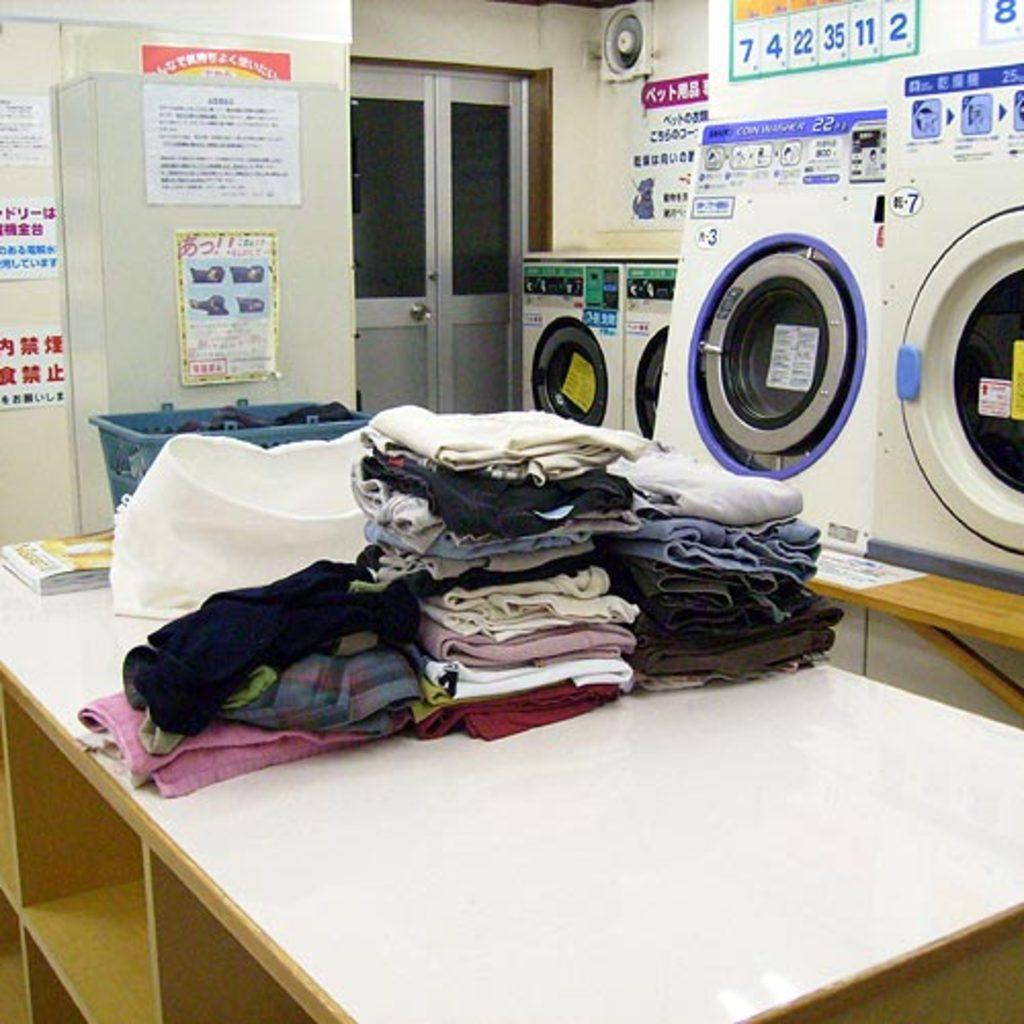What is the main piece of furniture in the image? The image contains a table. What items can be seen on the table? There are clothes, a basket, and a book on the table. What can be seen in the background of the image? There are washing machines, posters, and a cupboard in the background. What is the structure of the room visible in the image? The image contains a wall with a door in it. What type of crib is visible in the image? There is no crib present in the image. What kind of tools might a carpenter use in the image? There is no carpenter or tools present in the image. 